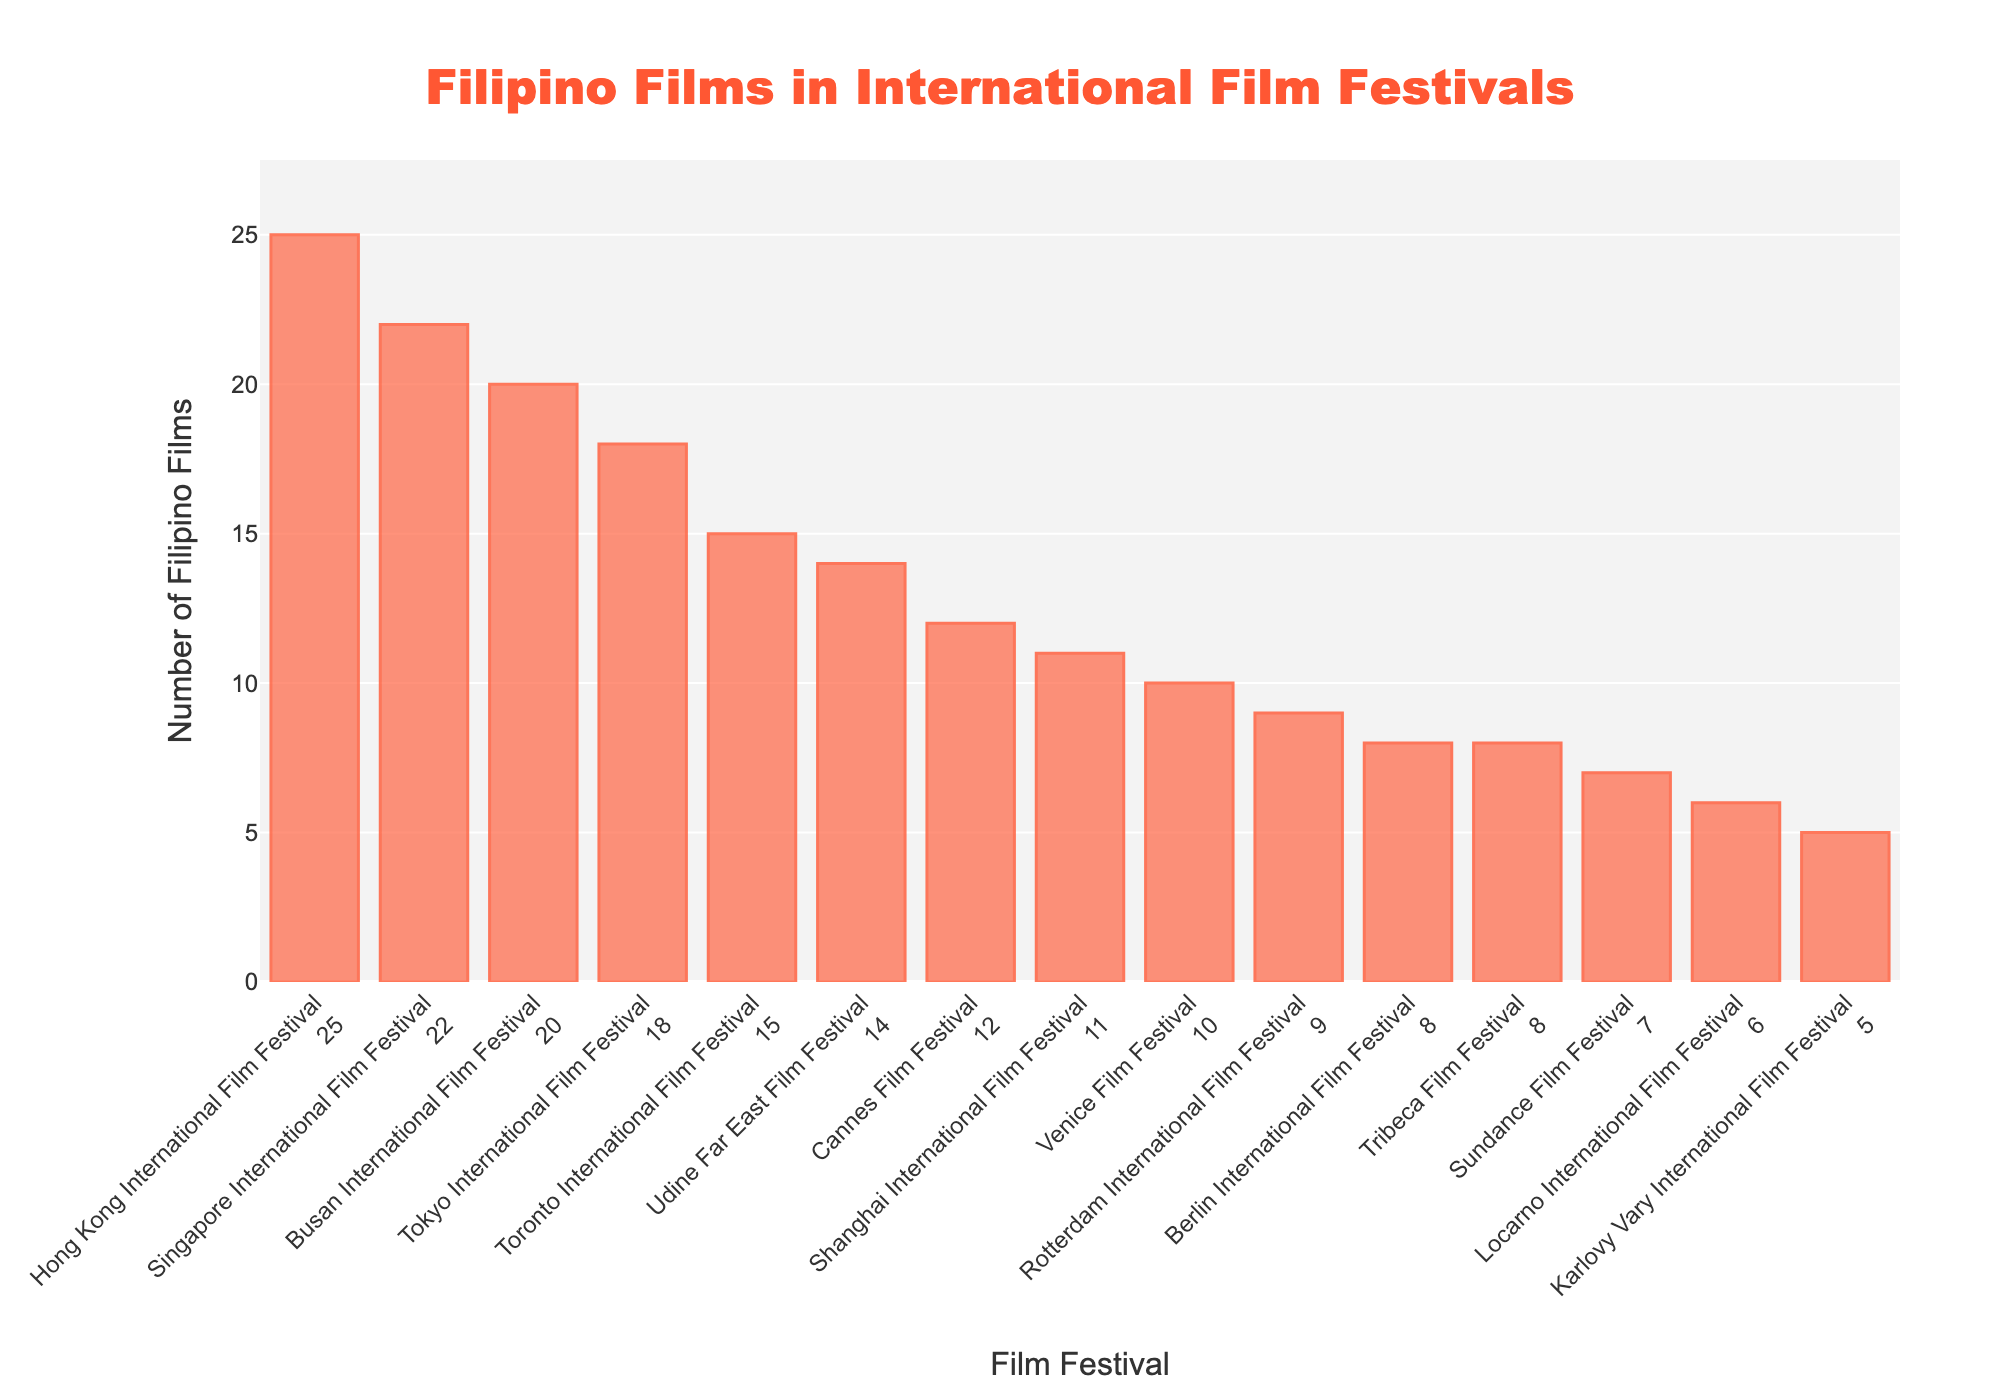Which film festival has the highest number of Filipino films? Look at the bar with the highest value. According to the chart, the Hong Kong International Film Festival has the highest number of Filipino films.
Answer: Hong Kong International Film Festival Which film festival has more Filipino films: Sundance Film Festival or Venice Film Festival? Check the heights of the bars for Sundance Film Festival and Venice Film Festival. Venice Film Festival has 10 Filipino films, while Sundance Film Festival has 7. Therefore, Venice Film Festival has more.
Answer: Venice Film Festival What's the total number of Filipino films in Cannes Film Festival, Berlin International Film Festival, and Venice Film Festival combined? Add the number of Filipino films for these festivals: Cannes Film Festival (12), Berlin International Film Festival (8), and Venice Film Festival (10). The total is 12 + 8 + 10 = 30.
Answer: 30 Which festival has fewer Filipino films: Tokyo International Film Festival or Locarno International Film Festival? Look at the bars for Tokyo International Film Festival and Locarno International Film Festival. Tokyo has 18 Filipino films whereas Locarno has 6. Therefore, Locarno has fewer.
Answer: Locarno International Film Festival How many more Filipino films are there in Busan International Film Festival compared to Toronto International Film Festival? Calculate the difference between the number of Filipino films in Busan (20) and Toronto (15). The difference is 20 - 15 = 5.
Answer: 5 Which two festivals have exactly 8 Filipino films each? Identify the bars with the value 8. According to the chart, Berlin International Film Festival and Tribeca Film Festival both have 8 Filipino films.
Answer: Berlin International Film Festival and Tribeca Film Festival What is the average number of Filipino films across all listed festivals? First, sum the total number of Filipino films across all festivals. The sum is 12 + 8 + 10 + 15 + 7 + 20 + 18 + 9 + 6 + 11 + 25 + 22 + 14 + 5 + 8 = 190. There are 15 festivals, so the average is 190 / 15 ≈ 12.67.
Answer: 12.67 Which festival has the more Filipino films: Shanghai International Film Festival or Udine Far East Film Festival? Compare the heights of the bars for Shanghai International Film Festival and Udine Far East Film Festival. Shanghai has 11 Filipino films, whereas Udine has 14. Udine Far East Film Festival has more.
Answer: Udine Far East Film Festival Is the number of Filipino films at the Karlovy Vary International Film Festival greater than the number at Locarno International Film Festival? Compare the bars for Karlovy Vary and Locarno. Karlovy Vary has 5 Filipino films and Locarno has 6, so Karlovy Vary has fewer than Locarno.
Answer: No 